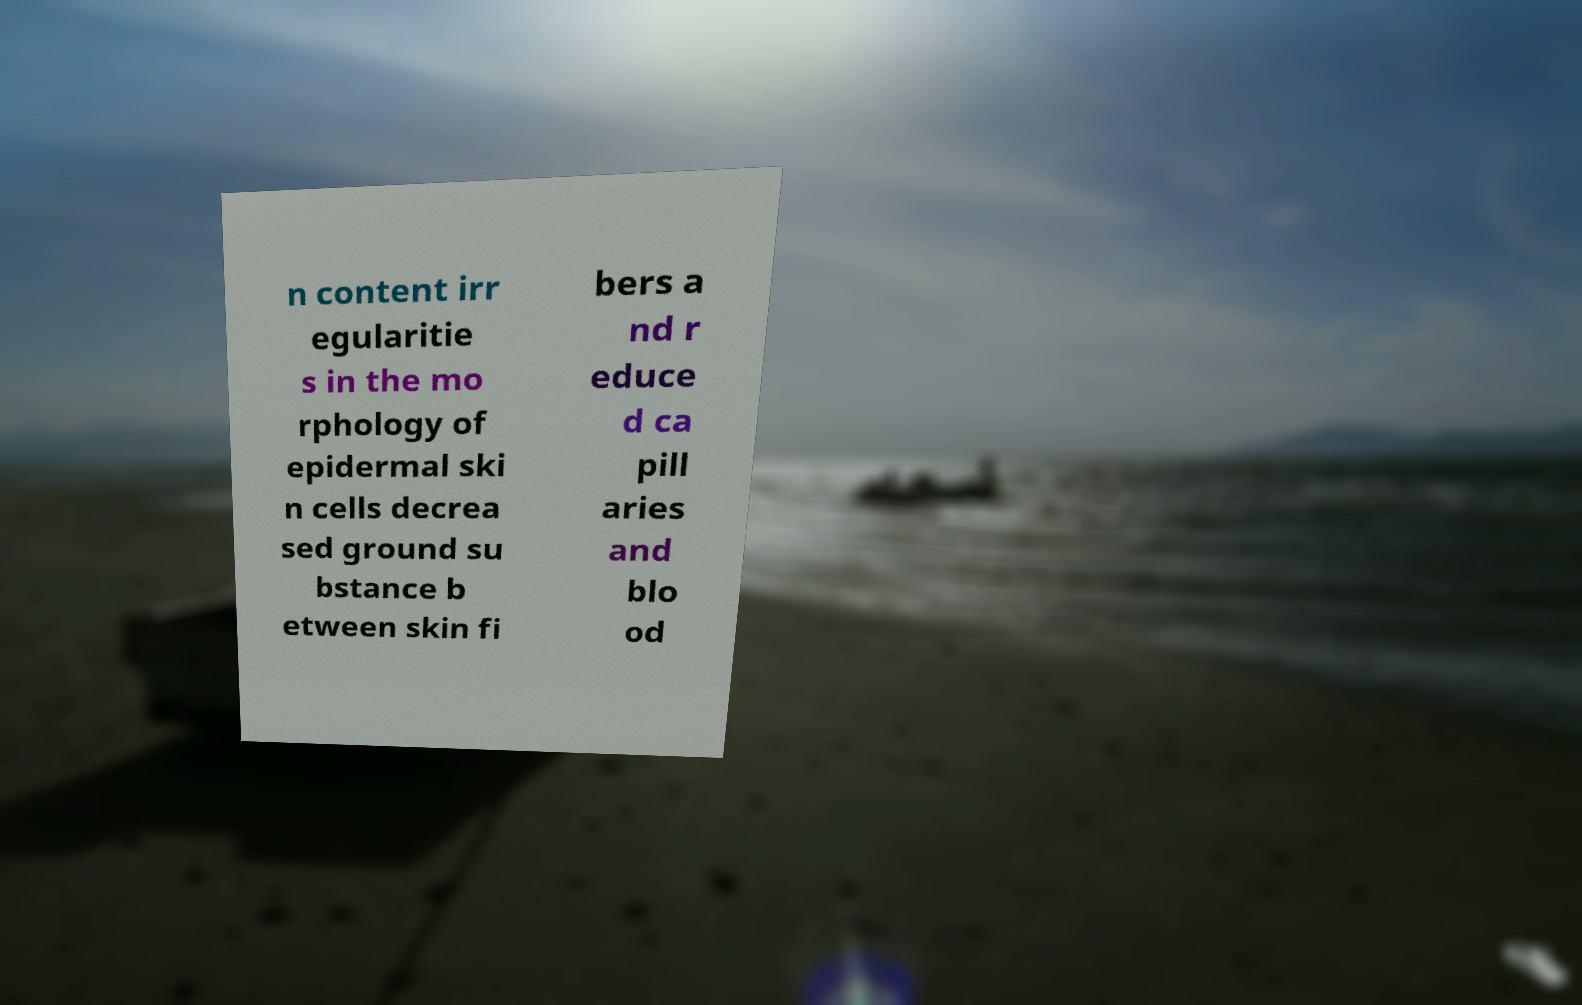For documentation purposes, I need the text within this image transcribed. Could you provide that? n content irr egularitie s in the mo rphology of epidermal ski n cells decrea sed ground su bstance b etween skin fi bers a nd r educe d ca pill aries and blo od 